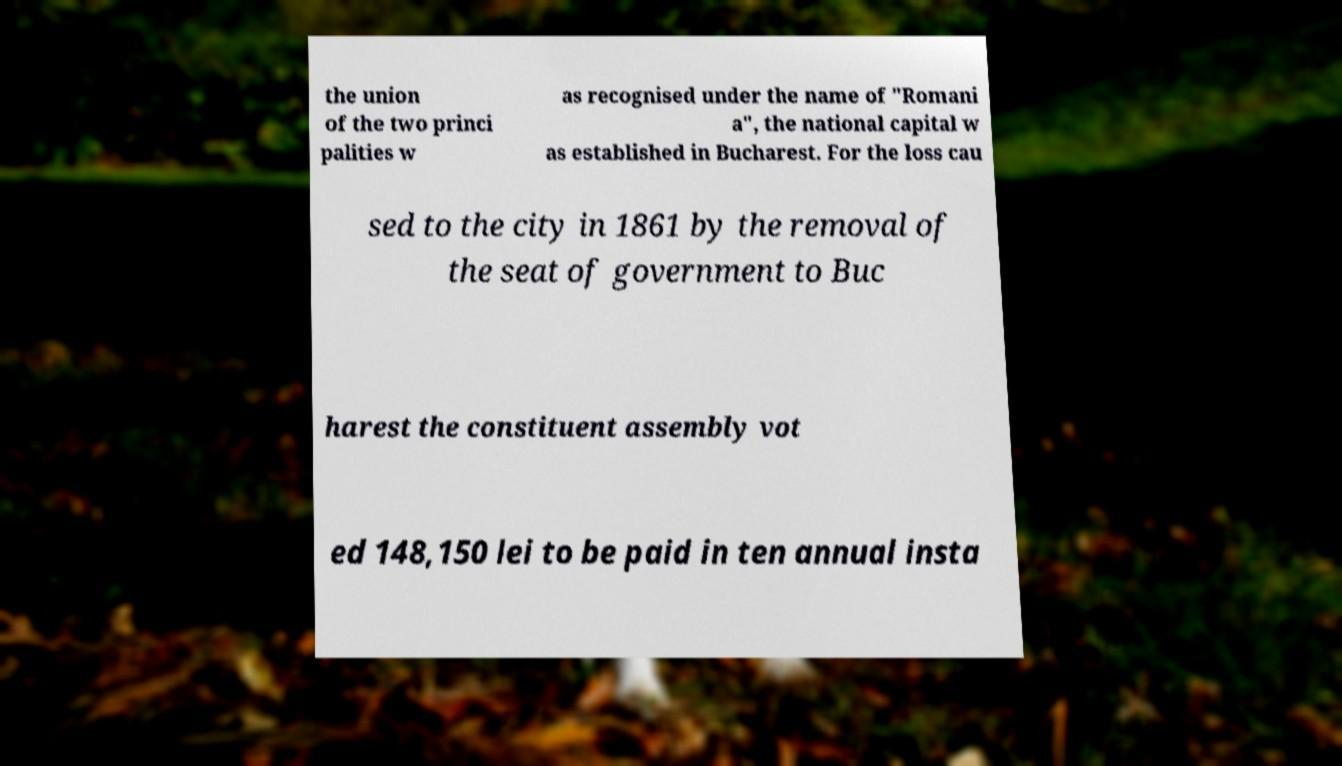Could you extract and type out the text from this image? the union of the two princi palities w as recognised under the name of "Romani a", the national capital w as established in Bucharest. For the loss cau sed to the city in 1861 by the removal of the seat of government to Buc harest the constituent assembly vot ed 148,150 lei to be paid in ten annual insta 